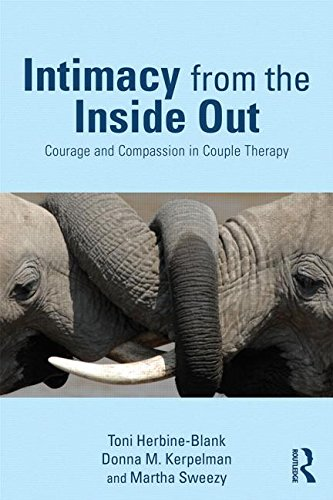What is the genre of this book? This book is best described as belonging to the genres of Psychology and Couple Therapy, offering insights into building intimacy using internal family systems therapy. 